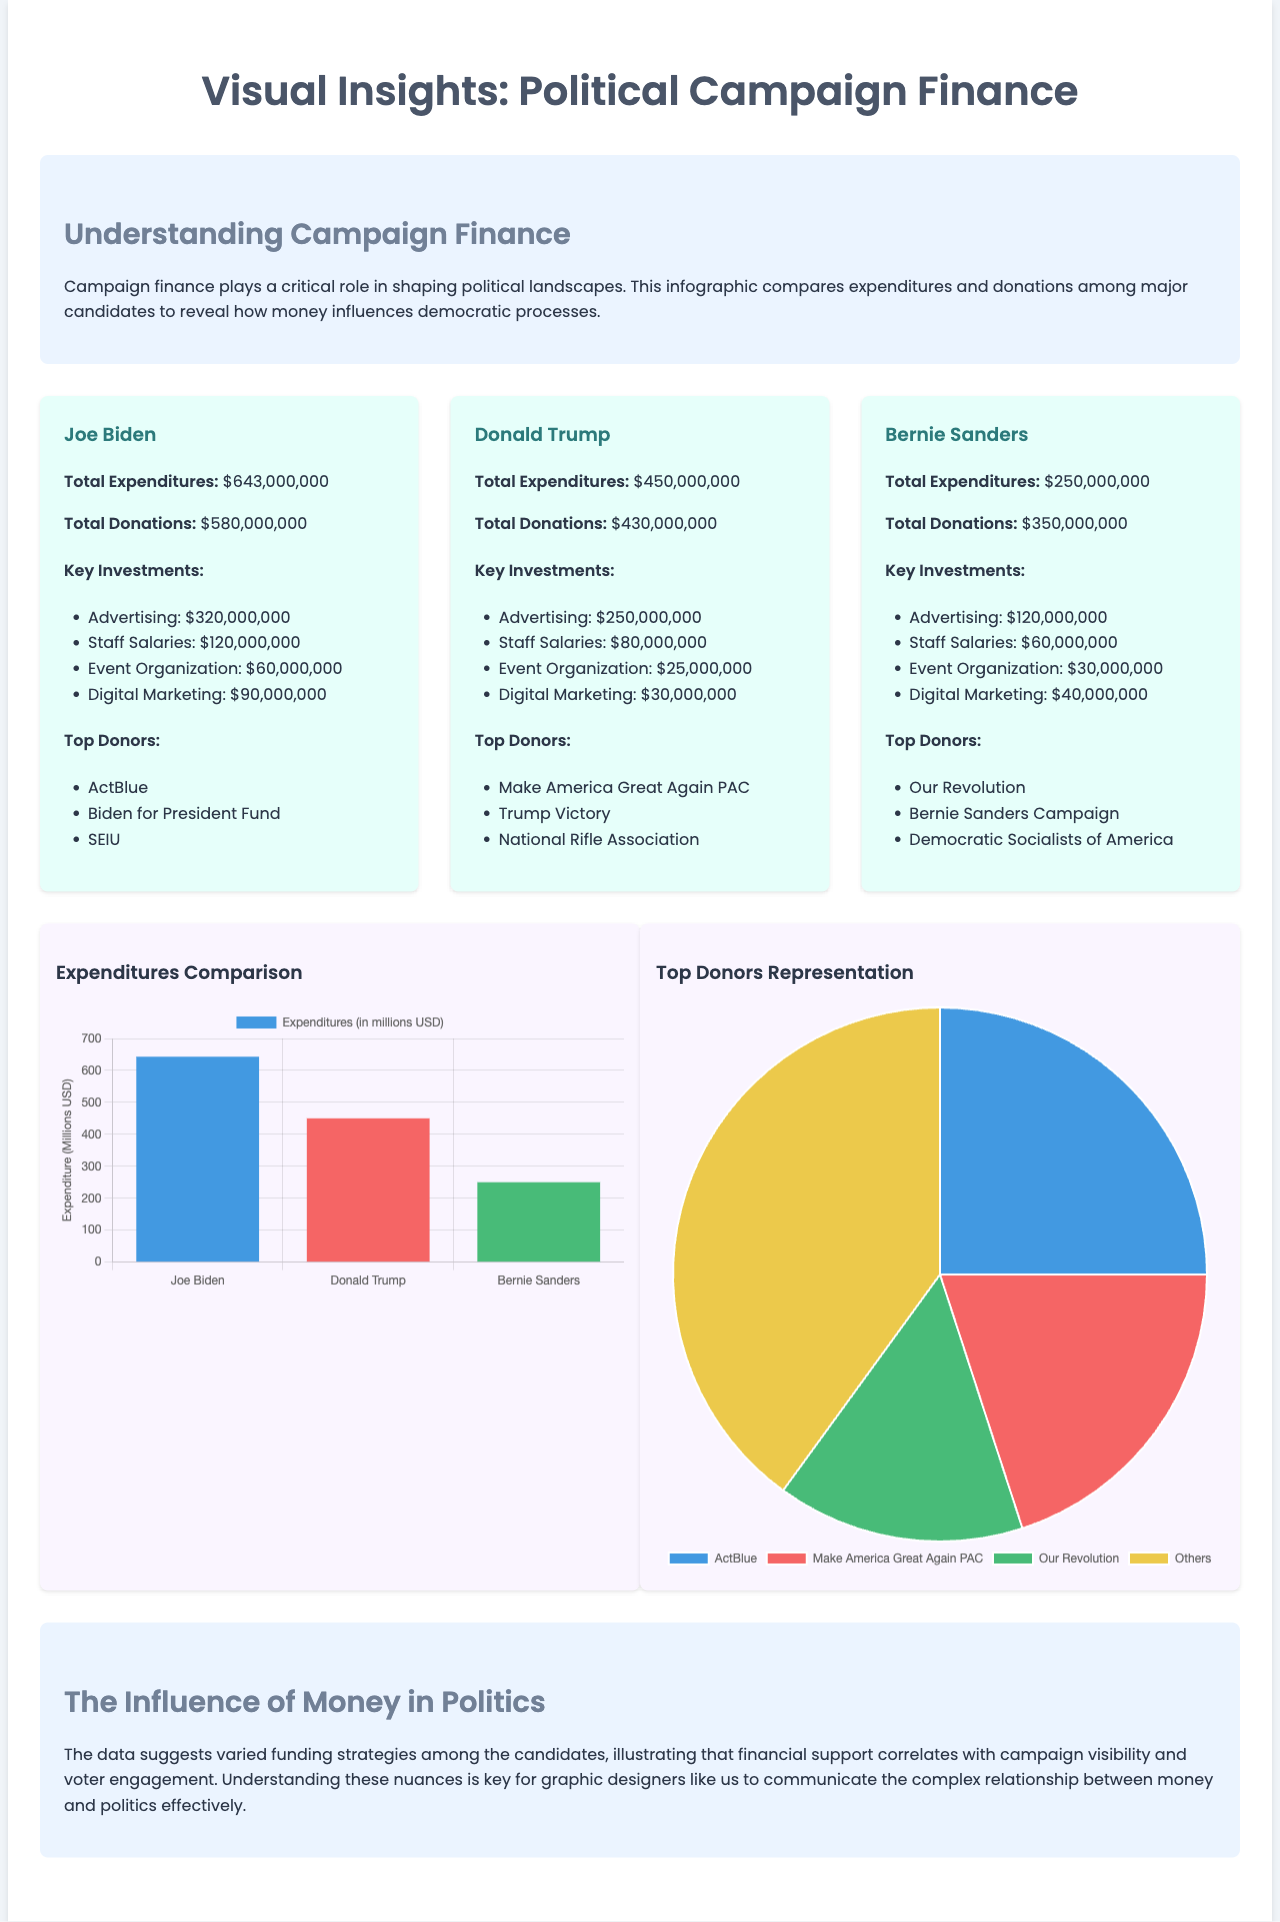What are Joe Biden's total expenditures? Joe Biden's total expenditures are specifically mentioned in the document as $643,000,000.
Answer: $643,000,000 Who are the top donors for Donald Trump? The document lists Donald Trump's top donors, which include Make America Great Again PAC, Trump Victory, and National Rifle Association.
Answer: Make America Great Again PAC, Trump Victory, National Rifle Association What is the total amount of donations for Bernie Sanders? The document indicates that the total donations for Bernie Sanders are $350,000,000.
Answer: $350,000,000 Which candidate has the highest expenditures? By comparing the expenditures listed for each candidate in the document, it is determined that Joe Biden has the highest expenditures.
Answer: Joe Biden How much did Bernie Sanders spend on advertising? The document specifies that Bernie Sanders spent $120,000,000 on advertising as part of his key investments.
Answer: $120,000,000 What is the purpose of the pie chart in the document? The pie chart is used to represent the shares of top donors, allowing for a visual comparison of contributions by major donor entities to the candidates.
Answer: Top donors representation What is the total expenditure for Donald Trump? The document explicitly states that Donald Trump's total expenditure amounts to $450,000,000.
Answer: $450,000,000 Which visual representation shows expenditures among the candidates? The bar chart presents the comparison of expenditures for Joe Biden, Donald Trump, and Bernie Sanders, illustrating financial data visually.
Answer: Expenditures comparison What background color is used for the candidate cards? The candidate cards feature a background color of #e6fffa as described in the styling of the document.
Answer: #e6fffa 